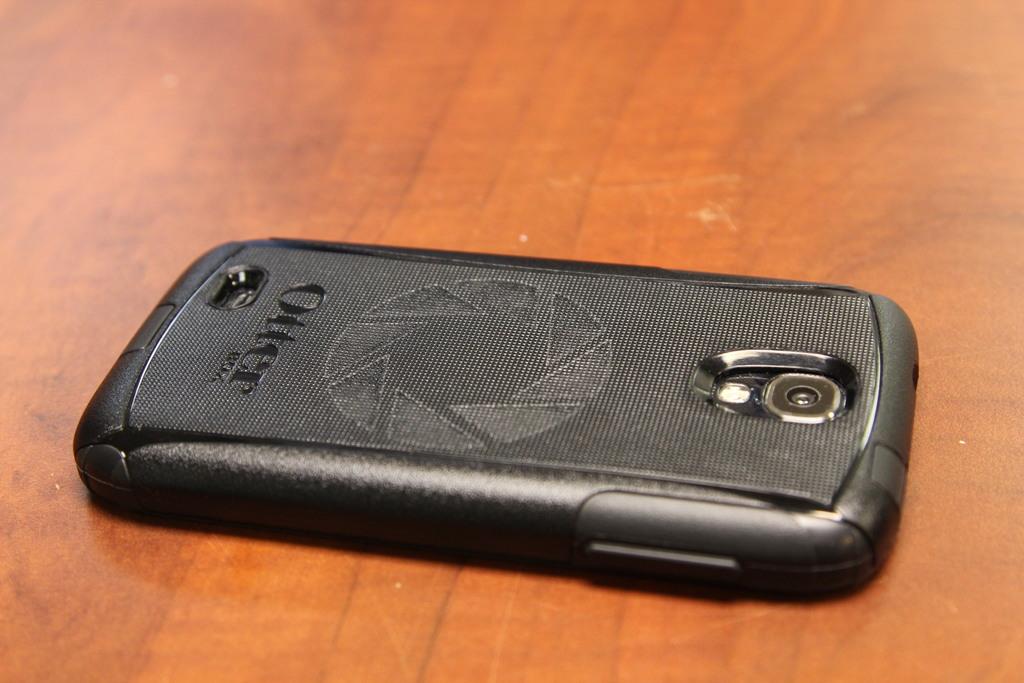What three letter word is displayed underneath otter?
Keep it short and to the point. Box. 